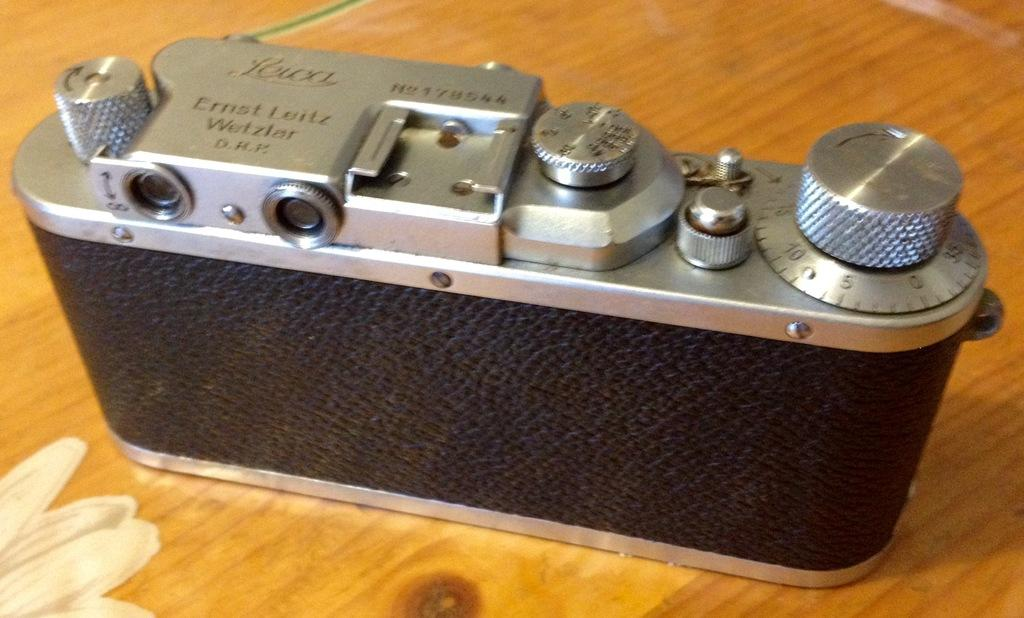What object is the main subject of the image? There is a camera in the image. Where is the camera located? The camera is on a table. Can you see a duck playing basketball in the image? No, there is no duck or basketball present in the image. 